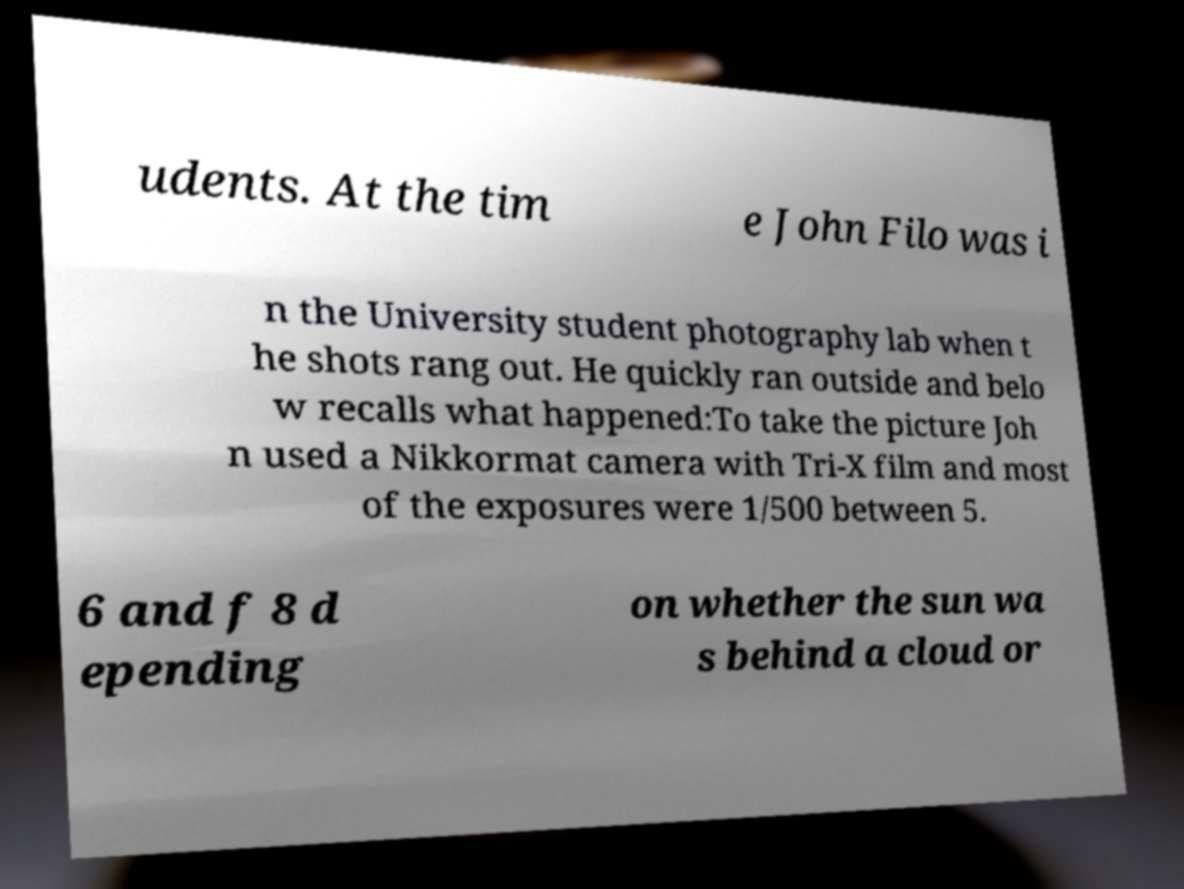Please identify and transcribe the text found in this image. udents. At the tim e John Filo was i n the University student photography lab when t he shots rang out. He quickly ran outside and belo w recalls what happened:To take the picture Joh n used a Nikkormat camera with Tri-X film and most of the exposures were 1/500 between 5. 6 and f 8 d epending on whether the sun wa s behind a cloud or 